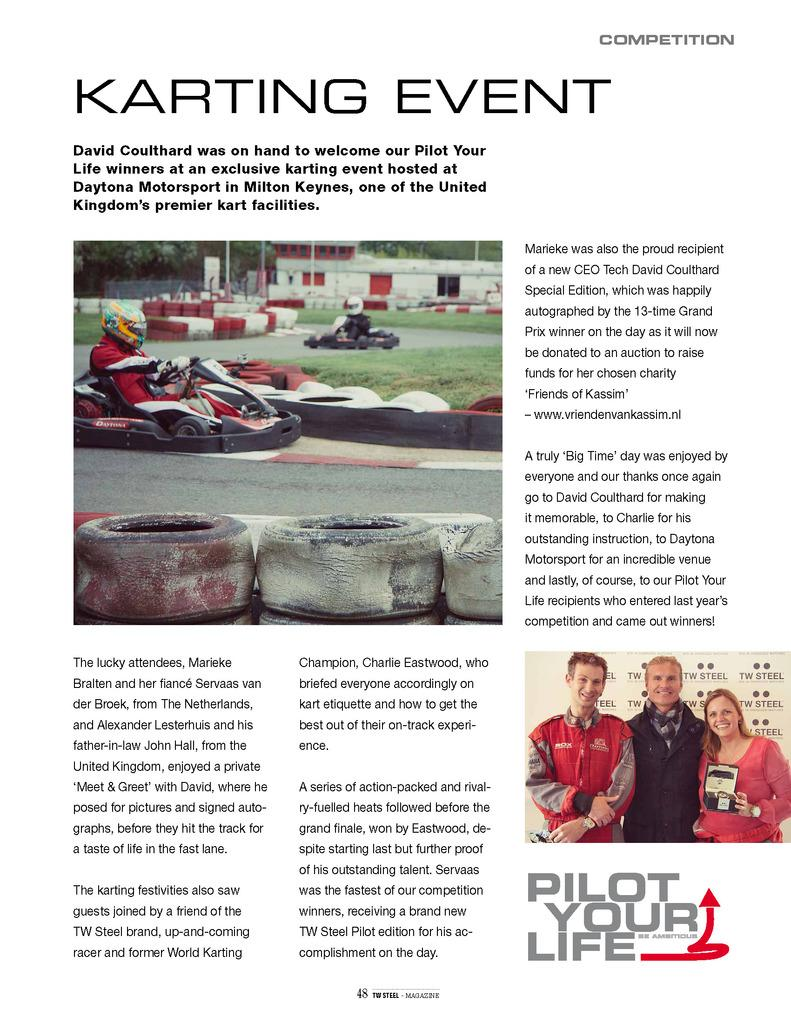How many images are present in the picture? There are two images in the picture. What can be found beside the images? There is something written beside the images. What can be found below the images? There is something written below the images. What can be found above the images? There is something written above the images. How many bikes are parked in front of the images? There is no information about bikes in the image, as the facts only mention the presence of images and written text. 